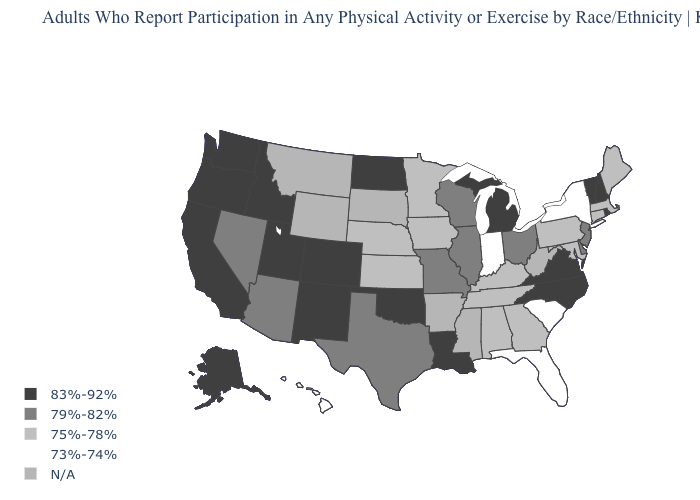Name the states that have a value in the range N/A?
Answer briefly. Arkansas, Mississippi, Montana, South Dakota, West Virginia, Wyoming. Which states have the lowest value in the USA?
Give a very brief answer. Florida, Hawaii, Indiana, New York, South Carolina. Name the states that have a value in the range 75%-78%?
Concise answer only. Alabama, Connecticut, Georgia, Iowa, Kansas, Kentucky, Maine, Maryland, Massachusetts, Minnesota, Nebraska, Pennsylvania, Tennessee. Which states hav the highest value in the MidWest?
Quick response, please. Michigan, North Dakota. What is the highest value in the West ?
Short answer required. 83%-92%. Does Idaho have the highest value in the USA?
Short answer required. Yes. Name the states that have a value in the range 73%-74%?
Answer briefly. Florida, Hawaii, Indiana, New York, South Carolina. Does Virginia have the lowest value in the South?
Quick response, please. No. Does the map have missing data?
Give a very brief answer. Yes. What is the value of Georgia?
Keep it brief. 75%-78%. What is the highest value in states that border Iowa?
Give a very brief answer. 79%-82%. Among the states that border Colorado , which have the highest value?
Answer briefly. New Mexico, Oklahoma, Utah. What is the value of Connecticut?
Write a very short answer. 75%-78%. 